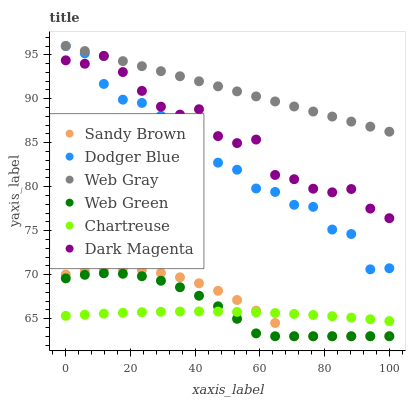Does Chartreuse have the minimum area under the curve?
Answer yes or no. Yes. Does Web Gray have the maximum area under the curve?
Answer yes or no. Yes. Does Dark Magenta have the minimum area under the curve?
Answer yes or no. No. Does Dark Magenta have the maximum area under the curve?
Answer yes or no. No. Is Web Gray the smoothest?
Answer yes or no. Yes. Is Dodger Blue the roughest?
Answer yes or no. Yes. Is Dark Magenta the smoothest?
Answer yes or no. No. Is Dark Magenta the roughest?
Answer yes or no. No. Does Web Green have the lowest value?
Answer yes or no. Yes. Does Dark Magenta have the lowest value?
Answer yes or no. No. Does Dodger Blue have the highest value?
Answer yes or no. Yes. Does Dark Magenta have the highest value?
Answer yes or no. No. Is Web Green less than Dark Magenta?
Answer yes or no. Yes. Is Dark Magenta greater than Sandy Brown?
Answer yes or no. Yes. Does Dodger Blue intersect Dark Magenta?
Answer yes or no. Yes. Is Dodger Blue less than Dark Magenta?
Answer yes or no. No. Is Dodger Blue greater than Dark Magenta?
Answer yes or no. No. Does Web Green intersect Dark Magenta?
Answer yes or no. No. 